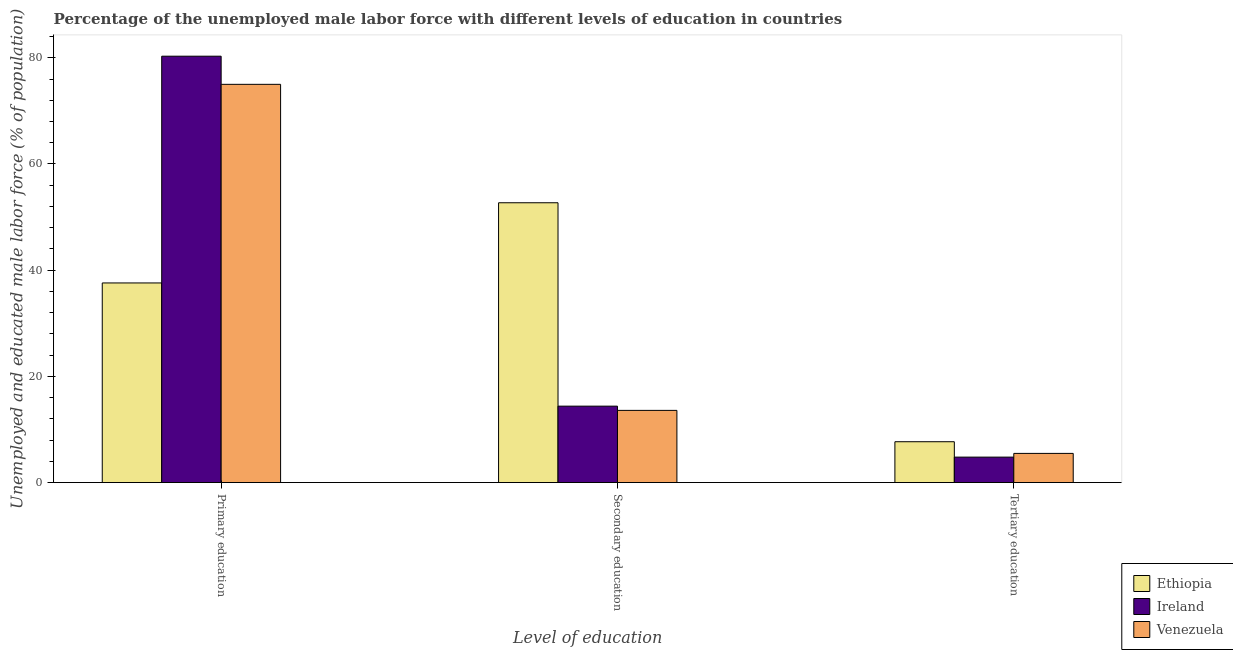How many different coloured bars are there?
Make the answer very short. 3. How many groups of bars are there?
Offer a terse response. 3. What is the label of the 2nd group of bars from the left?
Offer a terse response. Secondary education. What is the percentage of male labor force who received primary education in Ethiopia?
Your response must be concise. 37.6. Across all countries, what is the maximum percentage of male labor force who received secondary education?
Your answer should be very brief. 52.7. Across all countries, what is the minimum percentage of male labor force who received secondary education?
Your response must be concise. 13.6. In which country was the percentage of male labor force who received secondary education maximum?
Offer a terse response. Ethiopia. In which country was the percentage of male labor force who received primary education minimum?
Provide a succinct answer. Ethiopia. What is the total percentage of male labor force who received primary education in the graph?
Offer a terse response. 192.9. What is the difference between the percentage of male labor force who received tertiary education in Ethiopia and that in Venezuela?
Provide a short and direct response. 2.2. What is the difference between the percentage of male labor force who received secondary education in Ireland and the percentage of male labor force who received primary education in Venezuela?
Provide a short and direct response. -60.6. What is the average percentage of male labor force who received primary education per country?
Offer a terse response. 64.3. What is the difference between the percentage of male labor force who received primary education and percentage of male labor force who received tertiary education in Venezuela?
Provide a succinct answer. 69.5. What is the ratio of the percentage of male labor force who received primary education in Venezuela to that in Ethiopia?
Offer a terse response. 1.99. What is the difference between the highest and the second highest percentage of male labor force who received tertiary education?
Your answer should be very brief. 2.2. What is the difference between the highest and the lowest percentage of male labor force who received secondary education?
Make the answer very short. 39.1. Is the sum of the percentage of male labor force who received tertiary education in Ethiopia and Venezuela greater than the maximum percentage of male labor force who received primary education across all countries?
Your answer should be compact. No. What does the 2nd bar from the left in Primary education represents?
Provide a short and direct response. Ireland. What does the 3rd bar from the right in Secondary education represents?
Give a very brief answer. Ethiopia. How many bars are there?
Provide a short and direct response. 9. How many countries are there in the graph?
Ensure brevity in your answer.  3. What is the difference between two consecutive major ticks on the Y-axis?
Give a very brief answer. 20. Does the graph contain any zero values?
Offer a terse response. No. How many legend labels are there?
Your answer should be compact. 3. How are the legend labels stacked?
Keep it short and to the point. Vertical. What is the title of the graph?
Give a very brief answer. Percentage of the unemployed male labor force with different levels of education in countries. What is the label or title of the X-axis?
Keep it short and to the point. Level of education. What is the label or title of the Y-axis?
Your answer should be compact. Unemployed and educated male labor force (% of population). What is the Unemployed and educated male labor force (% of population) of Ethiopia in Primary education?
Your answer should be very brief. 37.6. What is the Unemployed and educated male labor force (% of population) of Ireland in Primary education?
Your response must be concise. 80.3. What is the Unemployed and educated male labor force (% of population) of Venezuela in Primary education?
Offer a terse response. 75. What is the Unemployed and educated male labor force (% of population) of Ethiopia in Secondary education?
Ensure brevity in your answer.  52.7. What is the Unemployed and educated male labor force (% of population) in Ireland in Secondary education?
Make the answer very short. 14.4. What is the Unemployed and educated male labor force (% of population) in Venezuela in Secondary education?
Ensure brevity in your answer.  13.6. What is the Unemployed and educated male labor force (% of population) in Ethiopia in Tertiary education?
Your response must be concise. 7.7. What is the Unemployed and educated male labor force (% of population) in Ireland in Tertiary education?
Offer a terse response. 4.8. Across all Level of education, what is the maximum Unemployed and educated male labor force (% of population) in Ethiopia?
Provide a succinct answer. 52.7. Across all Level of education, what is the maximum Unemployed and educated male labor force (% of population) in Ireland?
Give a very brief answer. 80.3. Across all Level of education, what is the minimum Unemployed and educated male labor force (% of population) in Ethiopia?
Your answer should be very brief. 7.7. Across all Level of education, what is the minimum Unemployed and educated male labor force (% of population) of Ireland?
Offer a terse response. 4.8. What is the total Unemployed and educated male labor force (% of population) of Ethiopia in the graph?
Keep it short and to the point. 98. What is the total Unemployed and educated male labor force (% of population) in Ireland in the graph?
Offer a terse response. 99.5. What is the total Unemployed and educated male labor force (% of population) in Venezuela in the graph?
Your answer should be compact. 94.1. What is the difference between the Unemployed and educated male labor force (% of population) of Ethiopia in Primary education and that in Secondary education?
Your answer should be compact. -15.1. What is the difference between the Unemployed and educated male labor force (% of population) in Ireland in Primary education and that in Secondary education?
Give a very brief answer. 65.9. What is the difference between the Unemployed and educated male labor force (% of population) in Venezuela in Primary education and that in Secondary education?
Your response must be concise. 61.4. What is the difference between the Unemployed and educated male labor force (% of population) in Ethiopia in Primary education and that in Tertiary education?
Provide a short and direct response. 29.9. What is the difference between the Unemployed and educated male labor force (% of population) in Ireland in Primary education and that in Tertiary education?
Provide a succinct answer. 75.5. What is the difference between the Unemployed and educated male labor force (% of population) of Venezuela in Primary education and that in Tertiary education?
Ensure brevity in your answer.  69.5. What is the difference between the Unemployed and educated male labor force (% of population) in Ireland in Secondary education and that in Tertiary education?
Your response must be concise. 9.6. What is the difference between the Unemployed and educated male labor force (% of population) of Venezuela in Secondary education and that in Tertiary education?
Your answer should be very brief. 8.1. What is the difference between the Unemployed and educated male labor force (% of population) in Ethiopia in Primary education and the Unemployed and educated male labor force (% of population) in Ireland in Secondary education?
Offer a terse response. 23.2. What is the difference between the Unemployed and educated male labor force (% of population) in Ethiopia in Primary education and the Unemployed and educated male labor force (% of population) in Venezuela in Secondary education?
Your response must be concise. 24. What is the difference between the Unemployed and educated male labor force (% of population) in Ireland in Primary education and the Unemployed and educated male labor force (% of population) in Venezuela in Secondary education?
Offer a very short reply. 66.7. What is the difference between the Unemployed and educated male labor force (% of population) of Ethiopia in Primary education and the Unemployed and educated male labor force (% of population) of Ireland in Tertiary education?
Offer a very short reply. 32.8. What is the difference between the Unemployed and educated male labor force (% of population) in Ethiopia in Primary education and the Unemployed and educated male labor force (% of population) in Venezuela in Tertiary education?
Ensure brevity in your answer.  32.1. What is the difference between the Unemployed and educated male labor force (% of population) in Ireland in Primary education and the Unemployed and educated male labor force (% of population) in Venezuela in Tertiary education?
Give a very brief answer. 74.8. What is the difference between the Unemployed and educated male labor force (% of population) in Ethiopia in Secondary education and the Unemployed and educated male labor force (% of population) in Ireland in Tertiary education?
Give a very brief answer. 47.9. What is the difference between the Unemployed and educated male labor force (% of population) in Ethiopia in Secondary education and the Unemployed and educated male labor force (% of population) in Venezuela in Tertiary education?
Offer a terse response. 47.2. What is the average Unemployed and educated male labor force (% of population) of Ethiopia per Level of education?
Ensure brevity in your answer.  32.67. What is the average Unemployed and educated male labor force (% of population) in Ireland per Level of education?
Provide a short and direct response. 33.17. What is the average Unemployed and educated male labor force (% of population) in Venezuela per Level of education?
Provide a short and direct response. 31.37. What is the difference between the Unemployed and educated male labor force (% of population) in Ethiopia and Unemployed and educated male labor force (% of population) in Ireland in Primary education?
Your answer should be very brief. -42.7. What is the difference between the Unemployed and educated male labor force (% of population) in Ethiopia and Unemployed and educated male labor force (% of population) in Venezuela in Primary education?
Make the answer very short. -37.4. What is the difference between the Unemployed and educated male labor force (% of population) of Ethiopia and Unemployed and educated male labor force (% of population) of Ireland in Secondary education?
Offer a very short reply. 38.3. What is the difference between the Unemployed and educated male labor force (% of population) of Ethiopia and Unemployed and educated male labor force (% of population) of Venezuela in Secondary education?
Provide a short and direct response. 39.1. What is the difference between the Unemployed and educated male labor force (% of population) of Ethiopia and Unemployed and educated male labor force (% of population) of Ireland in Tertiary education?
Keep it short and to the point. 2.9. What is the difference between the Unemployed and educated male labor force (% of population) in Ethiopia and Unemployed and educated male labor force (% of population) in Venezuela in Tertiary education?
Your answer should be compact. 2.2. What is the ratio of the Unemployed and educated male labor force (% of population) of Ethiopia in Primary education to that in Secondary education?
Give a very brief answer. 0.71. What is the ratio of the Unemployed and educated male labor force (% of population) of Ireland in Primary education to that in Secondary education?
Give a very brief answer. 5.58. What is the ratio of the Unemployed and educated male labor force (% of population) of Venezuela in Primary education to that in Secondary education?
Ensure brevity in your answer.  5.51. What is the ratio of the Unemployed and educated male labor force (% of population) of Ethiopia in Primary education to that in Tertiary education?
Give a very brief answer. 4.88. What is the ratio of the Unemployed and educated male labor force (% of population) of Ireland in Primary education to that in Tertiary education?
Offer a terse response. 16.73. What is the ratio of the Unemployed and educated male labor force (% of population) in Venezuela in Primary education to that in Tertiary education?
Your response must be concise. 13.64. What is the ratio of the Unemployed and educated male labor force (% of population) of Ethiopia in Secondary education to that in Tertiary education?
Make the answer very short. 6.84. What is the ratio of the Unemployed and educated male labor force (% of population) of Ireland in Secondary education to that in Tertiary education?
Your answer should be very brief. 3. What is the ratio of the Unemployed and educated male labor force (% of population) in Venezuela in Secondary education to that in Tertiary education?
Offer a very short reply. 2.47. What is the difference between the highest and the second highest Unemployed and educated male labor force (% of population) in Ethiopia?
Your response must be concise. 15.1. What is the difference between the highest and the second highest Unemployed and educated male labor force (% of population) in Ireland?
Offer a very short reply. 65.9. What is the difference between the highest and the second highest Unemployed and educated male labor force (% of population) in Venezuela?
Make the answer very short. 61.4. What is the difference between the highest and the lowest Unemployed and educated male labor force (% of population) in Ireland?
Your answer should be very brief. 75.5. What is the difference between the highest and the lowest Unemployed and educated male labor force (% of population) of Venezuela?
Your answer should be very brief. 69.5. 